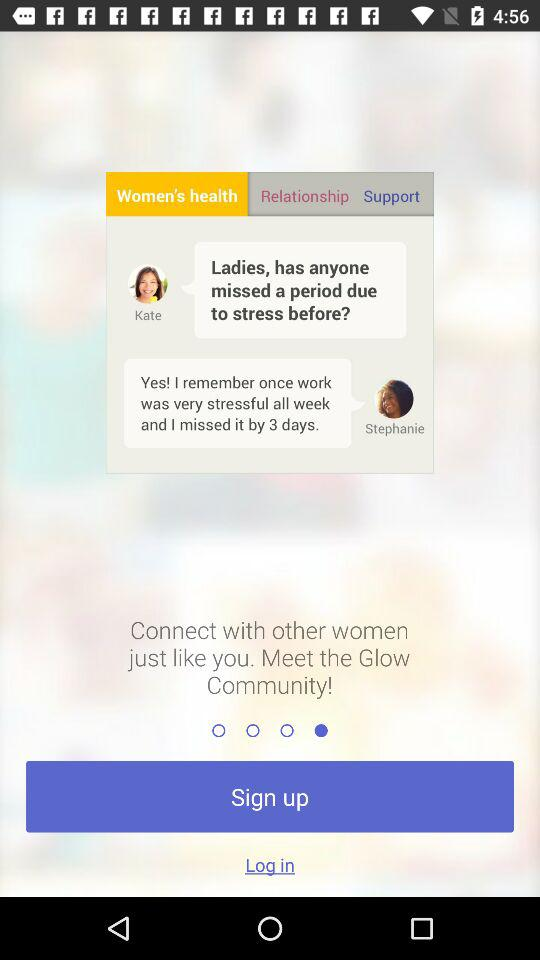How many people are in the chat?
Answer the question using a single word or phrase. 2 